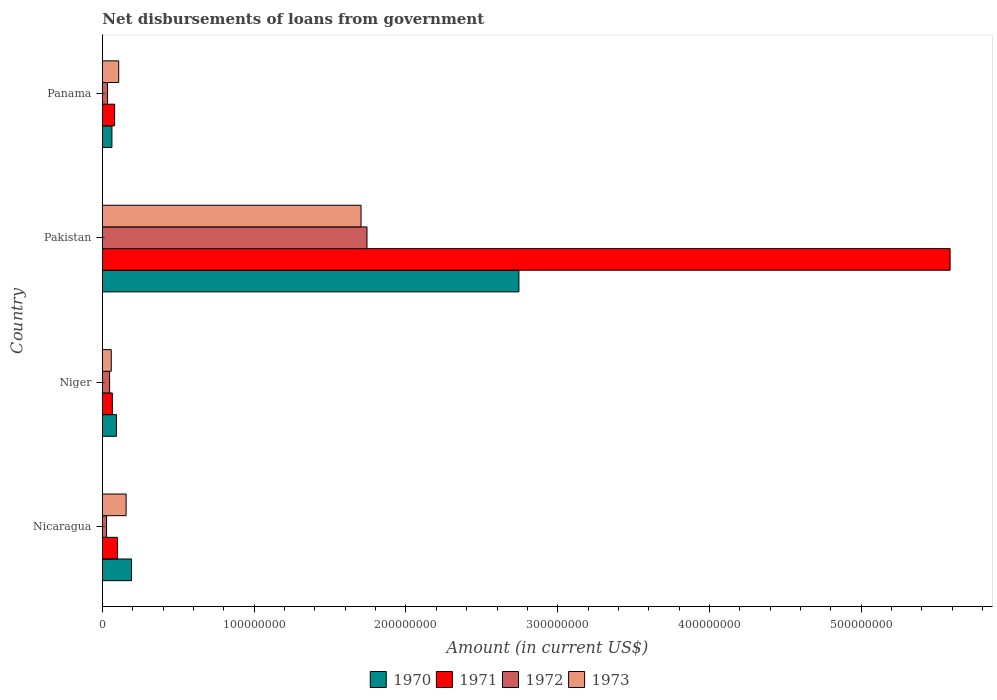Are the number of bars on each tick of the Y-axis equal?
Offer a terse response. Yes. How many bars are there on the 3rd tick from the bottom?
Your response must be concise. 4. In how many cases, is the number of bars for a given country not equal to the number of legend labels?
Give a very brief answer. 0. What is the amount of loan disbursed from government in 1970 in Niger?
Provide a succinct answer. 9.21e+06. Across all countries, what is the maximum amount of loan disbursed from government in 1971?
Make the answer very short. 5.59e+08. Across all countries, what is the minimum amount of loan disbursed from government in 1971?
Provide a succinct answer. 6.50e+06. In which country was the amount of loan disbursed from government in 1970 minimum?
Your response must be concise. Panama. What is the total amount of loan disbursed from government in 1972 in the graph?
Make the answer very short. 1.85e+08. What is the difference between the amount of loan disbursed from government in 1970 in Nicaragua and that in Pakistan?
Give a very brief answer. -2.55e+08. What is the difference between the amount of loan disbursed from government in 1970 in Panama and the amount of loan disbursed from government in 1973 in Pakistan?
Keep it short and to the point. -1.64e+08. What is the average amount of loan disbursed from government in 1970 per country?
Your answer should be very brief. 7.73e+07. What is the difference between the amount of loan disbursed from government in 1971 and amount of loan disbursed from government in 1973 in Nicaragua?
Offer a very short reply. -5.66e+06. What is the ratio of the amount of loan disbursed from government in 1970 in Nicaragua to that in Panama?
Offer a very short reply. 3.07. Is the difference between the amount of loan disbursed from government in 1971 in Niger and Pakistan greater than the difference between the amount of loan disbursed from government in 1973 in Niger and Pakistan?
Your answer should be very brief. No. What is the difference between the highest and the second highest amount of loan disbursed from government in 1970?
Offer a very short reply. 2.55e+08. What is the difference between the highest and the lowest amount of loan disbursed from government in 1972?
Ensure brevity in your answer.  1.72e+08. What does the 2nd bar from the top in Panama represents?
Offer a terse response. 1972. What does the 3rd bar from the bottom in Niger represents?
Offer a terse response. 1972. Is it the case that in every country, the sum of the amount of loan disbursed from government in 1973 and amount of loan disbursed from government in 1971 is greater than the amount of loan disbursed from government in 1972?
Ensure brevity in your answer.  Yes. How many bars are there?
Give a very brief answer. 16. Are all the bars in the graph horizontal?
Offer a very short reply. Yes. Does the graph contain grids?
Provide a succinct answer. No. How many legend labels are there?
Offer a terse response. 4. What is the title of the graph?
Offer a very short reply. Net disbursements of loans from government. What is the label or title of the X-axis?
Give a very brief answer. Amount (in current US$). What is the Amount (in current US$) in 1970 in Nicaragua?
Offer a terse response. 1.91e+07. What is the Amount (in current US$) in 1971 in Nicaragua?
Offer a very short reply. 9.93e+06. What is the Amount (in current US$) in 1972 in Nicaragua?
Your answer should be compact. 2.70e+06. What is the Amount (in current US$) of 1973 in Nicaragua?
Provide a succinct answer. 1.56e+07. What is the Amount (in current US$) of 1970 in Niger?
Ensure brevity in your answer.  9.21e+06. What is the Amount (in current US$) in 1971 in Niger?
Your answer should be compact. 6.50e+06. What is the Amount (in current US$) of 1972 in Niger?
Your answer should be very brief. 4.70e+06. What is the Amount (in current US$) of 1973 in Niger?
Offer a terse response. 5.79e+06. What is the Amount (in current US$) of 1970 in Pakistan?
Offer a terse response. 2.74e+08. What is the Amount (in current US$) in 1971 in Pakistan?
Your answer should be very brief. 5.59e+08. What is the Amount (in current US$) of 1972 in Pakistan?
Your response must be concise. 1.74e+08. What is the Amount (in current US$) of 1973 in Pakistan?
Ensure brevity in your answer.  1.70e+08. What is the Amount (in current US$) in 1970 in Panama?
Offer a very short reply. 6.24e+06. What is the Amount (in current US$) in 1971 in Panama?
Your answer should be compact. 8.01e+06. What is the Amount (in current US$) of 1972 in Panama?
Provide a succinct answer. 3.34e+06. What is the Amount (in current US$) in 1973 in Panama?
Give a very brief answer. 1.07e+07. Across all countries, what is the maximum Amount (in current US$) in 1970?
Provide a succinct answer. 2.74e+08. Across all countries, what is the maximum Amount (in current US$) in 1971?
Offer a terse response. 5.59e+08. Across all countries, what is the maximum Amount (in current US$) of 1972?
Your answer should be compact. 1.74e+08. Across all countries, what is the maximum Amount (in current US$) in 1973?
Provide a succinct answer. 1.70e+08. Across all countries, what is the minimum Amount (in current US$) of 1970?
Offer a terse response. 6.24e+06. Across all countries, what is the minimum Amount (in current US$) of 1971?
Ensure brevity in your answer.  6.50e+06. Across all countries, what is the minimum Amount (in current US$) of 1972?
Your answer should be very brief. 2.70e+06. Across all countries, what is the minimum Amount (in current US$) in 1973?
Provide a succinct answer. 5.79e+06. What is the total Amount (in current US$) in 1970 in the graph?
Offer a very short reply. 3.09e+08. What is the total Amount (in current US$) of 1971 in the graph?
Ensure brevity in your answer.  5.83e+08. What is the total Amount (in current US$) of 1972 in the graph?
Offer a terse response. 1.85e+08. What is the total Amount (in current US$) in 1973 in the graph?
Offer a very short reply. 2.02e+08. What is the difference between the Amount (in current US$) in 1970 in Nicaragua and that in Niger?
Your response must be concise. 9.94e+06. What is the difference between the Amount (in current US$) of 1971 in Nicaragua and that in Niger?
Your answer should be very brief. 3.44e+06. What is the difference between the Amount (in current US$) of 1972 in Nicaragua and that in Niger?
Keep it short and to the point. -2.00e+06. What is the difference between the Amount (in current US$) of 1973 in Nicaragua and that in Niger?
Provide a succinct answer. 9.80e+06. What is the difference between the Amount (in current US$) of 1970 in Nicaragua and that in Pakistan?
Your answer should be very brief. -2.55e+08. What is the difference between the Amount (in current US$) of 1971 in Nicaragua and that in Pakistan?
Give a very brief answer. -5.49e+08. What is the difference between the Amount (in current US$) of 1972 in Nicaragua and that in Pakistan?
Give a very brief answer. -1.72e+08. What is the difference between the Amount (in current US$) of 1973 in Nicaragua and that in Pakistan?
Make the answer very short. -1.55e+08. What is the difference between the Amount (in current US$) of 1970 in Nicaragua and that in Panama?
Offer a terse response. 1.29e+07. What is the difference between the Amount (in current US$) of 1971 in Nicaragua and that in Panama?
Give a very brief answer. 1.92e+06. What is the difference between the Amount (in current US$) of 1972 in Nicaragua and that in Panama?
Keep it short and to the point. -6.45e+05. What is the difference between the Amount (in current US$) in 1973 in Nicaragua and that in Panama?
Your answer should be compact. 4.89e+06. What is the difference between the Amount (in current US$) of 1970 in Niger and that in Pakistan?
Keep it short and to the point. -2.65e+08. What is the difference between the Amount (in current US$) in 1971 in Niger and that in Pakistan?
Give a very brief answer. -5.52e+08. What is the difference between the Amount (in current US$) in 1972 in Niger and that in Pakistan?
Offer a very short reply. -1.70e+08. What is the difference between the Amount (in current US$) of 1973 in Niger and that in Pakistan?
Your answer should be compact. -1.65e+08. What is the difference between the Amount (in current US$) of 1970 in Niger and that in Panama?
Provide a short and direct response. 2.96e+06. What is the difference between the Amount (in current US$) in 1971 in Niger and that in Panama?
Keep it short and to the point. -1.51e+06. What is the difference between the Amount (in current US$) in 1972 in Niger and that in Panama?
Your answer should be compact. 1.36e+06. What is the difference between the Amount (in current US$) in 1973 in Niger and that in Panama?
Your answer should be compact. -4.91e+06. What is the difference between the Amount (in current US$) in 1970 in Pakistan and that in Panama?
Keep it short and to the point. 2.68e+08. What is the difference between the Amount (in current US$) in 1971 in Pakistan and that in Panama?
Offer a very short reply. 5.51e+08. What is the difference between the Amount (in current US$) of 1972 in Pakistan and that in Panama?
Make the answer very short. 1.71e+08. What is the difference between the Amount (in current US$) of 1973 in Pakistan and that in Panama?
Offer a terse response. 1.60e+08. What is the difference between the Amount (in current US$) in 1970 in Nicaragua and the Amount (in current US$) in 1971 in Niger?
Ensure brevity in your answer.  1.26e+07. What is the difference between the Amount (in current US$) in 1970 in Nicaragua and the Amount (in current US$) in 1972 in Niger?
Your answer should be very brief. 1.44e+07. What is the difference between the Amount (in current US$) in 1970 in Nicaragua and the Amount (in current US$) in 1973 in Niger?
Provide a succinct answer. 1.34e+07. What is the difference between the Amount (in current US$) in 1971 in Nicaragua and the Amount (in current US$) in 1972 in Niger?
Keep it short and to the point. 5.23e+06. What is the difference between the Amount (in current US$) in 1971 in Nicaragua and the Amount (in current US$) in 1973 in Niger?
Keep it short and to the point. 4.14e+06. What is the difference between the Amount (in current US$) of 1972 in Nicaragua and the Amount (in current US$) of 1973 in Niger?
Ensure brevity in your answer.  -3.09e+06. What is the difference between the Amount (in current US$) in 1970 in Nicaragua and the Amount (in current US$) in 1971 in Pakistan?
Offer a terse response. -5.39e+08. What is the difference between the Amount (in current US$) of 1970 in Nicaragua and the Amount (in current US$) of 1972 in Pakistan?
Offer a terse response. -1.55e+08. What is the difference between the Amount (in current US$) in 1970 in Nicaragua and the Amount (in current US$) in 1973 in Pakistan?
Ensure brevity in your answer.  -1.51e+08. What is the difference between the Amount (in current US$) of 1971 in Nicaragua and the Amount (in current US$) of 1972 in Pakistan?
Provide a succinct answer. -1.64e+08. What is the difference between the Amount (in current US$) in 1971 in Nicaragua and the Amount (in current US$) in 1973 in Pakistan?
Make the answer very short. -1.60e+08. What is the difference between the Amount (in current US$) of 1972 in Nicaragua and the Amount (in current US$) of 1973 in Pakistan?
Make the answer very short. -1.68e+08. What is the difference between the Amount (in current US$) in 1970 in Nicaragua and the Amount (in current US$) in 1971 in Panama?
Your answer should be very brief. 1.11e+07. What is the difference between the Amount (in current US$) in 1970 in Nicaragua and the Amount (in current US$) in 1972 in Panama?
Your answer should be compact. 1.58e+07. What is the difference between the Amount (in current US$) in 1970 in Nicaragua and the Amount (in current US$) in 1973 in Panama?
Your answer should be compact. 8.44e+06. What is the difference between the Amount (in current US$) in 1971 in Nicaragua and the Amount (in current US$) in 1972 in Panama?
Offer a terse response. 6.59e+06. What is the difference between the Amount (in current US$) in 1971 in Nicaragua and the Amount (in current US$) in 1973 in Panama?
Make the answer very short. -7.67e+05. What is the difference between the Amount (in current US$) of 1972 in Nicaragua and the Amount (in current US$) of 1973 in Panama?
Your answer should be very brief. -8.00e+06. What is the difference between the Amount (in current US$) of 1970 in Niger and the Amount (in current US$) of 1971 in Pakistan?
Your answer should be very brief. -5.49e+08. What is the difference between the Amount (in current US$) of 1970 in Niger and the Amount (in current US$) of 1972 in Pakistan?
Provide a short and direct response. -1.65e+08. What is the difference between the Amount (in current US$) of 1970 in Niger and the Amount (in current US$) of 1973 in Pakistan?
Keep it short and to the point. -1.61e+08. What is the difference between the Amount (in current US$) of 1971 in Niger and the Amount (in current US$) of 1972 in Pakistan?
Give a very brief answer. -1.68e+08. What is the difference between the Amount (in current US$) in 1971 in Niger and the Amount (in current US$) in 1973 in Pakistan?
Your response must be concise. -1.64e+08. What is the difference between the Amount (in current US$) in 1972 in Niger and the Amount (in current US$) in 1973 in Pakistan?
Provide a succinct answer. -1.66e+08. What is the difference between the Amount (in current US$) of 1970 in Niger and the Amount (in current US$) of 1971 in Panama?
Your response must be concise. 1.20e+06. What is the difference between the Amount (in current US$) of 1970 in Niger and the Amount (in current US$) of 1972 in Panama?
Offer a very short reply. 5.86e+06. What is the difference between the Amount (in current US$) of 1970 in Niger and the Amount (in current US$) of 1973 in Panama?
Ensure brevity in your answer.  -1.50e+06. What is the difference between the Amount (in current US$) of 1971 in Niger and the Amount (in current US$) of 1972 in Panama?
Offer a terse response. 3.15e+06. What is the difference between the Amount (in current US$) in 1971 in Niger and the Amount (in current US$) in 1973 in Panama?
Your answer should be compact. -4.21e+06. What is the difference between the Amount (in current US$) of 1972 in Niger and the Amount (in current US$) of 1973 in Panama?
Your answer should be very brief. -6.00e+06. What is the difference between the Amount (in current US$) of 1970 in Pakistan and the Amount (in current US$) of 1971 in Panama?
Give a very brief answer. 2.66e+08. What is the difference between the Amount (in current US$) of 1970 in Pakistan and the Amount (in current US$) of 1972 in Panama?
Keep it short and to the point. 2.71e+08. What is the difference between the Amount (in current US$) in 1970 in Pakistan and the Amount (in current US$) in 1973 in Panama?
Provide a short and direct response. 2.64e+08. What is the difference between the Amount (in current US$) in 1971 in Pakistan and the Amount (in current US$) in 1972 in Panama?
Your answer should be compact. 5.55e+08. What is the difference between the Amount (in current US$) in 1971 in Pakistan and the Amount (in current US$) in 1973 in Panama?
Your answer should be compact. 5.48e+08. What is the difference between the Amount (in current US$) in 1972 in Pakistan and the Amount (in current US$) in 1973 in Panama?
Make the answer very short. 1.64e+08. What is the average Amount (in current US$) of 1970 per country?
Provide a succinct answer. 7.73e+07. What is the average Amount (in current US$) of 1971 per country?
Make the answer very short. 1.46e+08. What is the average Amount (in current US$) in 1972 per country?
Keep it short and to the point. 4.63e+07. What is the average Amount (in current US$) of 1973 per country?
Provide a succinct answer. 5.06e+07. What is the difference between the Amount (in current US$) in 1970 and Amount (in current US$) in 1971 in Nicaragua?
Ensure brevity in your answer.  9.21e+06. What is the difference between the Amount (in current US$) of 1970 and Amount (in current US$) of 1972 in Nicaragua?
Keep it short and to the point. 1.64e+07. What is the difference between the Amount (in current US$) of 1970 and Amount (in current US$) of 1973 in Nicaragua?
Your answer should be very brief. 3.55e+06. What is the difference between the Amount (in current US$) in 1971 and Amount (in current US$) in 1972 in Nicaragua?
Offer a terse response. 7.23e+06. What is the difference between the Amount (in current US$) of 1971 and Amount (in current US$) of 1973 in Nicaragua?
Offer a terse response. -5.66e+06. What is the difference between the Amount (in current US$) of 1972 and Amount (in current US$) of 1973 in Nicaragua?
Give a very brief answer. -1.29e+07. What is the difference between the Amount (in current US$) in 1970 and Amount (in current US$) in 1971 in Niger?
Your response must be concise. 2.71e+06. What is the difference between the Amount (in current US$) in 1970 and Amount (in current US$) in 1972 in Niger?
Provide a short and direct response. 4.50e+06. What is the difference between the Amount (in current US$) in 1970 and Amount (in current US$) in 1973 in Niger?
Ensure brevity in your answer.  3.42e+06. What is the difference between the Amount (in current US$) of 1971 and Amount (in current US$) of 1972 in Niger?
Your answer should be compact. 1.79e+06. What is the difference between the Amount (in current US$) in 1971 and Amount (in current US$) in 1973 in Niger?
Provide a short and direct response. 7.04e+05. What is the difference between the Amount (in current US$) in 1972 and Amount (in current US$) in 1973 in Niger?
Make the answer very short. -1.09e+06. What is the difference between the Amount (in current US$) in 1970 and Amount (in current US$) in 1971 in Pakistan?
Ensure brevity in your answer.  -2.84e+08. What is the difference between the Amount (in current US$) of 1970 and Amount (in current US$) of 1972 in Pakistan?
Keep it short and to the point. 1.00e+08. What is the difference between the Amount (in current US$) in 1970 and Amount (in current US$) in 1973 in Pakistan?
Offer a terse response. 1.04e+08. What is the difference between the Amount (in current US$) of 1971 and Amount (in current US$) of 1972 in Pakistan?
Provide a short and direct response. 3.84e+08. What is the difference between the Amount (in current US$) of 1971 and Amount (in current US$) of 1973 in Pakistan?
Provide a short and direct response. 3.88e+08. What is the difference between the Amount (in current US$) of 1972 and Amount (in current US$) of 1973 in Pakistan?
Offer a very short reply. 3.90e+06. What is the difference between the Amount (in current US$) in 1970 and Amount (in current US$) in 1971 in Panama?
Ensure brevity in your answer.  -1.77e+06. What is the difference between the Amount (in current US$) of 1970 and Amount (in current US$) of 1972 in Panama?
Your answer should be very brief. 2.90e+06. What is the difference between the Amount (in current US$) in 1970 and Amount (in current US$) in 1973 in Panama?
Your response must be concise. -4.46e+06. What is the difference between the Amount (in current US$) of 1971 and Amount (in current US$) of 1972 in Panama?
Make the answer very short. 4.66e+06. What is the difference between the Amount (in current US$) of 1971 and Amount (in current US$) of 1973 in Panama?
Your response must be concise. -2.69e+06. What is the difference between the Amount (in current US$) in 1972 and Amount (in current US$) in 1973 in Panama?
Provide a short and direct response. -7.36e+06. What is the ratio of the Amount (in current US$) in 1970 in Nicaragua to that in Niger?
Offer a terse response. 2.08. What is the ratio of the Amount (in current US$) of 1971 in Nicaragua to that in Niger?
Give a very brief answer. 1.53. What is the ratio of the Amount (in current US$) of 1972 in Nicaragua to that in Niger?
Ensure brevity in your answer.  0.57. What is the ratio of the Amount (in current US$) in 1973 in Nicaragua to that in Niger?
Offer a terse response. 2.69. What is the ratio of the Amount (in current US$) in 1970 in Nicaragua to that in Pakistan?
Ensure brevity in your answer.  0.07. What is the ratio of the Amount (in current US$) in 1971 in Nicaragua to that in Pakistan?
Your response must be concise. 0.02. What is the ratio of the Amount (in current US$) of 1972 in Nicaragua to that in Pakistan?
Ensure brevity in your answer.  0.02. What is the ratio of the Amount (in current US$) in 1973 in Nicaragua to that in Pakistan?
Your answer should be very brief. 0.09. What is the ratio of the Amount (in current US$) of 1970 in Nicaragua to that in Panama?
Provide a short and direct response. 3.07. What is the ratio of the Amount (in current US$) in 1971 in Nicaragua to that in Panama?
Give a very brief answer. 1.24. What is the ratio of the Amount (in current US$) in 1972 in Nicaragua to that in Panama?
Keep it short and to the point. 0.81. What is the ratio of the Amount (in current US$) of 1973 in Nicaragua to that in Panama?
Ensure brevity in your answer.  1.46. What is the ratio of the Amount (in current US$) of 1970 in Niger to that in Pakistan?
Make the answer very short. 0.03. What is the ratio of the Amount (in current US$) in 1971 in Niger to that in Pakistan?
Give a very brief answer. 0.01. What is the ratio of the Amount (in current US$) of 1972 in Niger to that in Pakistan?
Provide a short and direct response. 0.03. What is the ratio of the Amount (in current US$) of 1973 in Niger to that in Pakistan?
Make the answer very short. 0.03. What is the ratio of the Amount (in current US$) of 1970 in Niger to that in Panama?
Your answer should be very brief. 1.48. What is the ratio of the Amount (in current US$) in 1971 in Niger to that in Panama?
Make the answer very short. 0.81. What is the ratio of the Amount (in current US$) of 1972 in Niger to that in Panama?
Provide a short and direct response. 1.41. What is the ratio of the Amount (in current US$) of 1973 in Niger to that in Panama?
Provide a short and direct response. 0.54. What is the ratio of the Amount (in current US$) of 1970 in Pakistan to that in Panama?
Offer a terse response. 43.96. What is the ratio of the Amount (in current US$) in 1971 in Pakistan to that in Panama?
Offer a terse response. 69.73. What is the ratio of the Amount (in current US$) of 1972 in Pakistan to that in Panama?
Offer a terse response. 52.11. What is the ratio of the Amount (in current US$) of 1973 in Pakistan to that in Panama?
Your answer should be very brief. 15.92. What is the difference between the highest and the second highest Amount (in current US$) in 1970?
Give a very brief answer. 2.55e+08. What is the difference between the highest and the second highest Amount (in current US$) in 1971?
Keep it short and to the point. 5.49e+08. What is the difference between the highest and the second highest Amount (in current US$) in 1972?
Keep it short and to the point. 1.70e+08. What is the difference between the highest and the second highest Amount (in current US$) in 1973?
Give a very brief answer. 1.55e+08. What is the difference between the highest and the lowest Amount (in current US$) in 1970?
Your answer should be very brief. 2.68e+08. What is the difference between the highest and the lowest Amount (in current US$) in 1971?
Your response must be concise. 5.52e+08. What is the difference between the highest and the lowest Amount (in current US$) of 1972?
Provide a succinct answer. 1.72e+08. What is the difference between the highest and the lowest Amount (in current US$) in 1973?
Your answer should be very brief. 1.65e+08. 